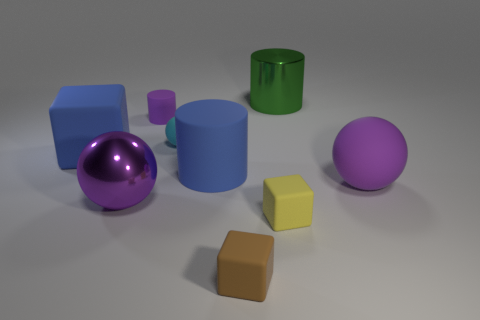Add 1 tiny purple blocks. How many objects exist? 10 Subtract all cylinders. How many objects are left? 6 Subtract all big brown rubber cubes. Subtract all matte cubes. How many objects are left? 6 Add 7 tiny purple objects. How many tiny purple objects are left? 8 Add 6 brown things. How many brown things exist? 7 Subtract 0 red spheres. How many objects are left? 9 